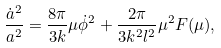<formula> <loc_0><loc_0><loc_500><loc_500>\frac { \dot { a } ^ { 2 } } { a ^ { 2 } } = \frac { 8 \pi } { 3 k } \mu { \dot { \phi } } ^ { 2 } + \frac { 2 \pi } { 3 k ^ { 2 } l ^ { 2 } } \mu ^ { 2 } F ( \mu ) ,</formula> 